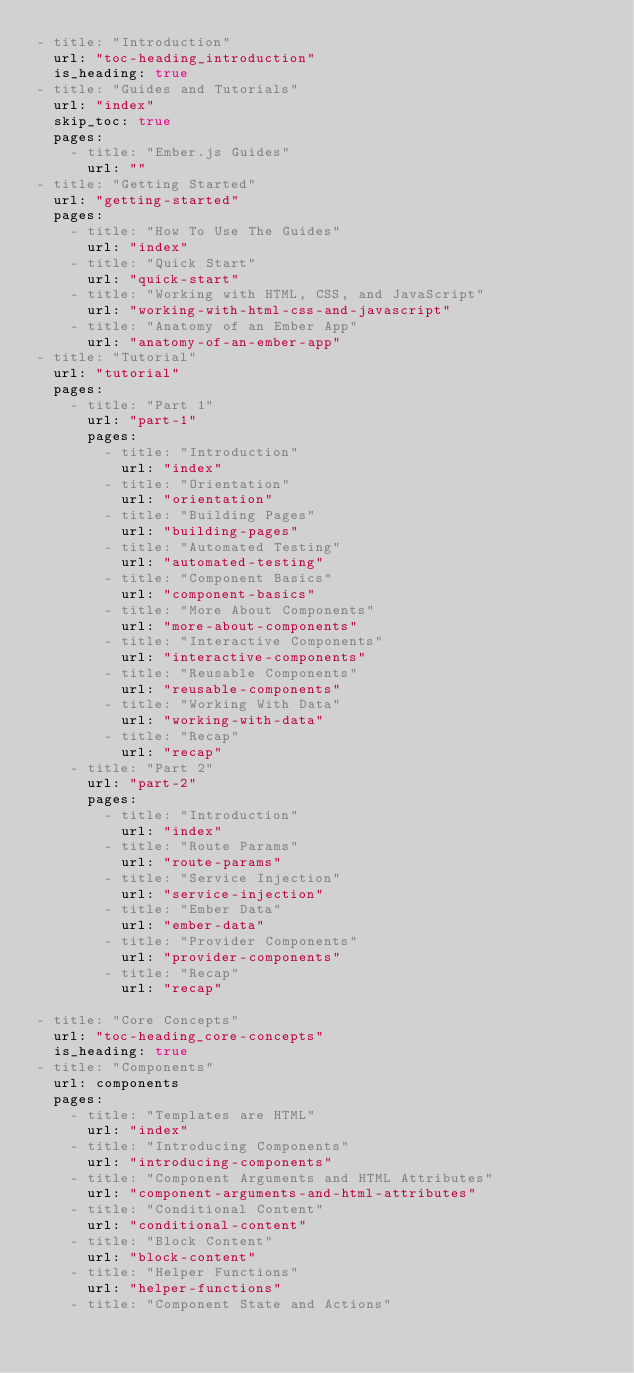<code> <loc_0><loc_0><loc_500><loc_500><_YAML_>- title: "Introduction"
  url: "toc-heading_introduction"
  is_heading: true
- title: "Guides and Tutorials"
  url: "index"
  skip_toc: true
  pages:
    - title: "Ember.js Guides"
      url: ""
- title: "Getting Started"
  url: "getting-started"
  pages:
    - title: "How To Use The Guides"
      url: "index"
    - title: "Quick Start"
      url: "quick-start"
    - title: "Working with HTML, CSS, and JavaScript"
      url: "working-with-html-css-and-javascript"
    - title: "Anatomy of an Ember App"
      url: "anatomy-of-an-ember-app"
- title: "Tutorial"
  url: "tutorial"
  pages:
    - title: "Part 1"
      url: "part-1"
      pages:
        - title: "Introduction"
          url: "index"
        - title: "Orientation"
          url: "orientation"
        - title: "Building Pages"
          url: "building-pages"
        - title: "Automated Testing"
          url: "automated-testing"
        - title: "Component Basics"
          url: "component-basics"
        - title: "More About Components"
          url: "more-about-components"
        - title: "Interactive Components"
          url: "interactive-components"
        - title: "Reusable Components"
          url: "reusable-components"
        - title: "Working With Data"
          url: "working-with-data"
        - title: "Recap"
          url: "recap"
    - title: "Part 2"
      url: "part-2"
      pages:
        - title: "Introduction"
          url: "index"
        - title: "Route Params"
          url: "route-params"
        - title: "Service Injection"
          url: "service-injection"
        - title: "Ember Data"
          url: "ember-data"
        - title: "Provider Components"
          url: "provider-components"
        - title: "Recap"
          url: "recap"

- title: "Core Concepts"
  url: "toc-heading_core-concepts"
  is_heading: true
- title: "Components"
  url: components
  pages:
    - title: "Templates are HTML"
      url: "index"
    - title: "Introducing Components"
      url: "introducing-components"
    - title: "Component Arguments and HTML Attributes"
      url: "component-arguments-and-html-attributes"
    - title: "Conditional Content"
      url: "conditional-content"
    - title: "Block Content"
      url: "block-content"
    - title: "Helper Functions"
      url: "helper-functions"
    - title: "Component State and Actions"</code> 